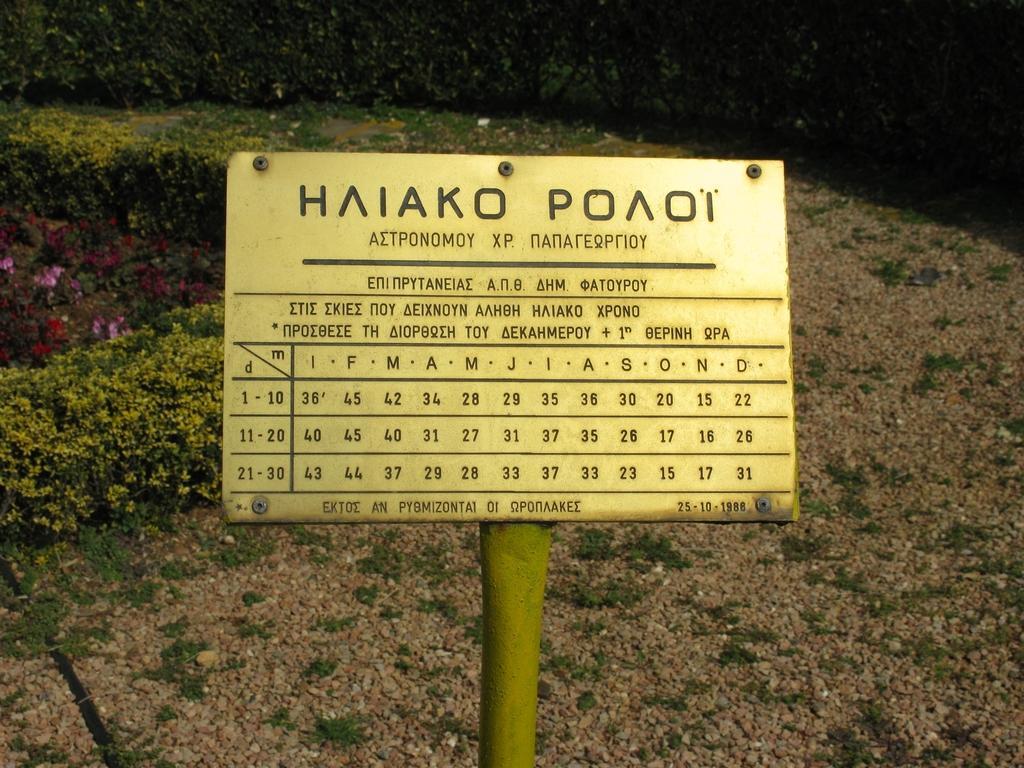Describe this image in one or two sentences. In this image we can see a board with some text in the middle of the image and there are some plants and flowers. 